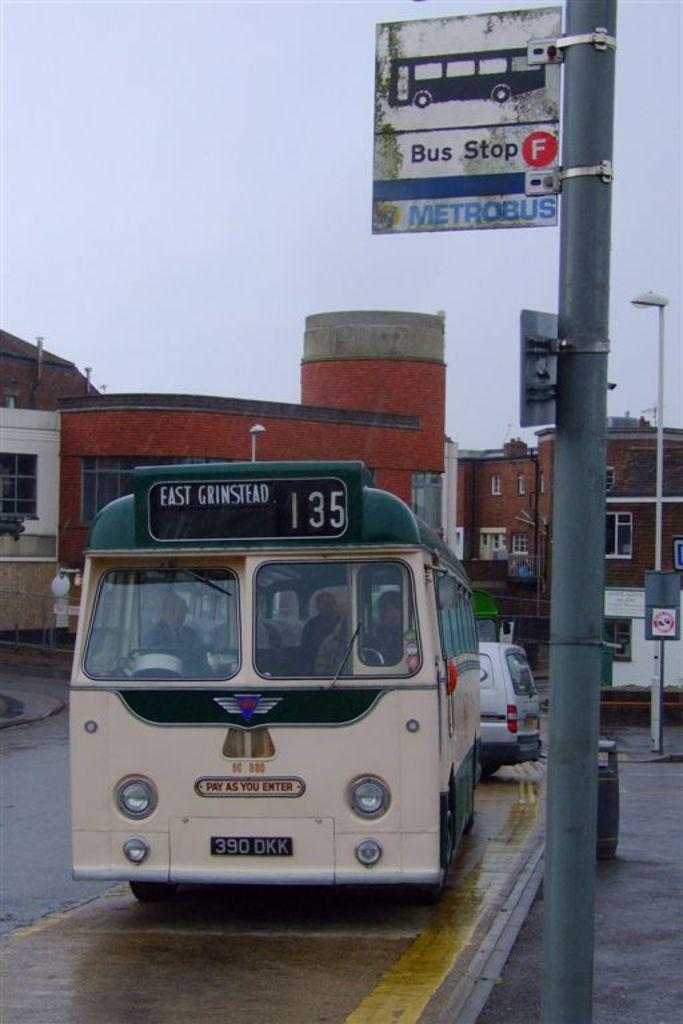What types of objects are present in the image? There are vehicles and boards attached to poles in the image. What can be seen in the background of the image? There are buildings and the sky visible in the background of the image. What type of lip can be seen on the vehicles in the image? There is no lip present on the vehicles in the image. Is there any toothpaste visible in the image? There is no toothpaste present in the image. 